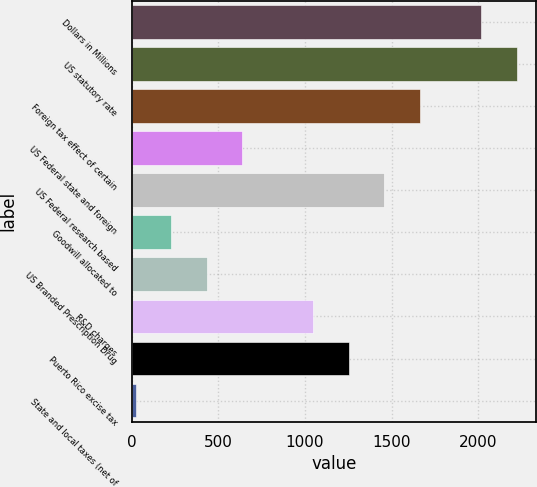Convert chart to OTSL. <chart><loc_0><loc_0><loc_500><loc_500><bar_chart><fcel>Dollars in Millions<fcel>US statutory rate<fcel>Foreign tax effect of certain<fcel>US Federal state and foreign<fcel>US Federal research based<fcel>Goodwill allocated to<fcel>US Branded Prescription Drug<fcel>R&D charges<fcel>Puerto Rico excise tax<fcel>State and local taxes (net of<nl><fcel>2016<fcel>2220.7<fcel>1660.6<fcel>637.1<fcel>1455.9<fcel>227.7<fcel>432.4<fcel>1046.5<fcel>1251.2<fcel>23<nl></chart> 